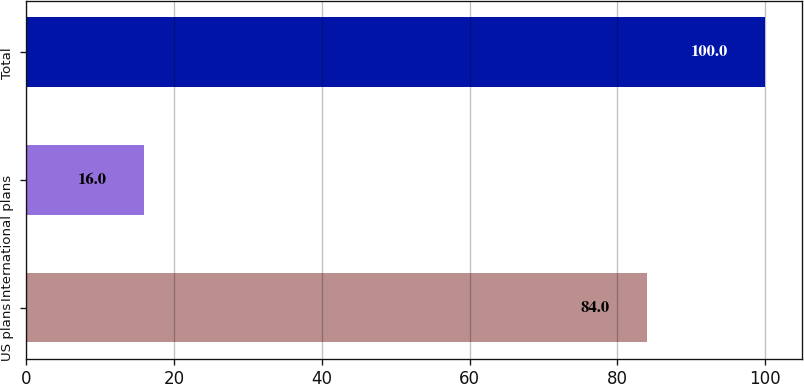<chart> <loc_0><loc_0><loc_500><loc_500><bar_chart><fcel>US plans<fcel>International plans<fcel>Total<nl><fcel>84<fcel>16<fcel>100<nl></chart> 